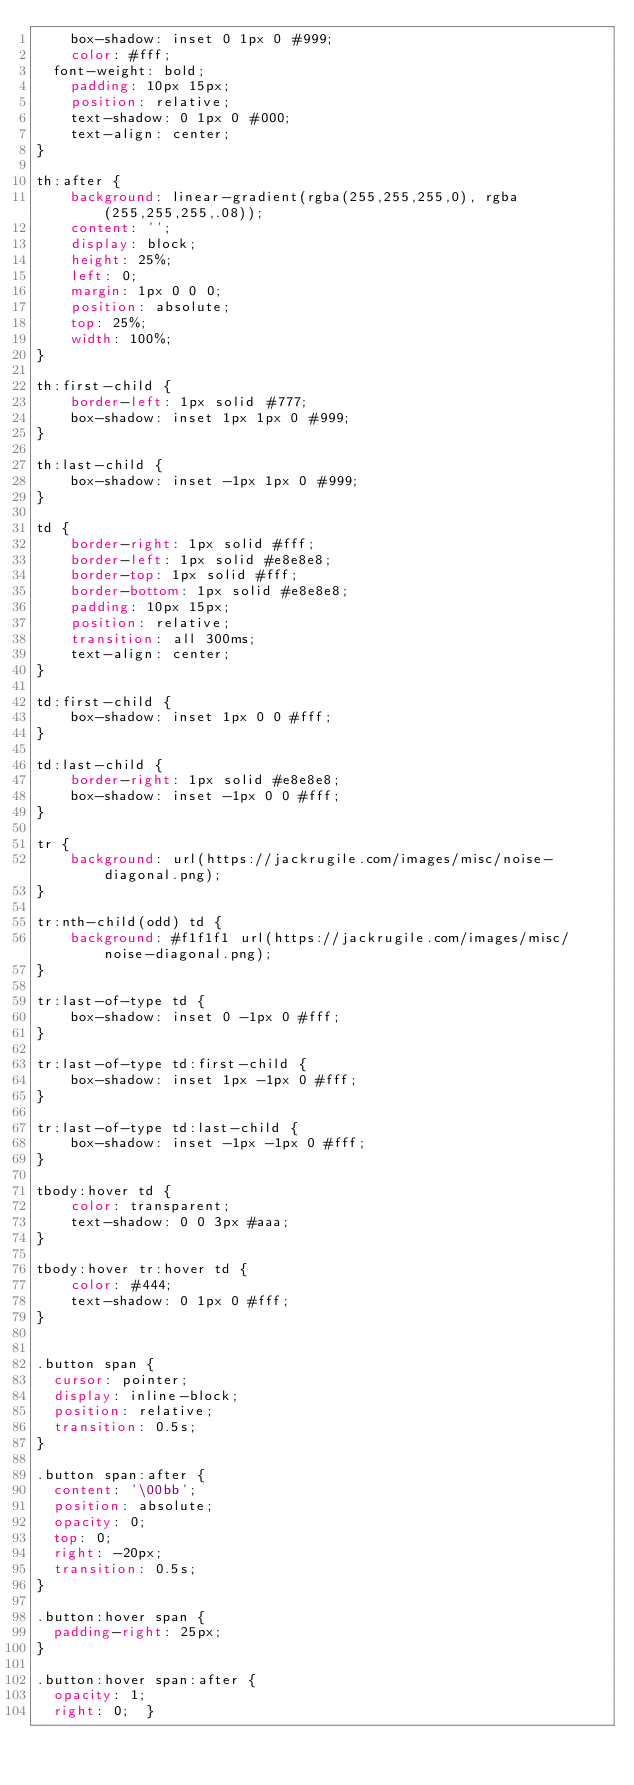Convert code to text. <code><loc_0><loc_0><loc_500><loc_500><_CSS_>	box-shadow: inset 0 1px 0 #999;
	color: #fff;
  font-weight: bold;
	padding: 10px 15px;
	position: relative;
	text-shadow: 0 1px 0 #000;	
	text-align: center;
}

th:after {
	background: linear-gradient(rgba(255,255,255,0), rgba(255,255,255,.08));
	content: '';
	display: block;
	height: 25%;
	left: 0;
	margin: 1px 0 0 0;
	position: absolute;
	top: 25%;
	width: 100%;
}

th:first-child {
	border-left: 1px solid #777;	
	box-shadow: inset 1px 1px 0 #999;
}

th:last-child {
	box-shadow: inset -1px 1px 0 #999;
}

td {
	border-right: 1px solid #fff;
	border-left: 1px solid #e8e8e8;
	border-top: 1px solid #fff;
	border-bottom: 1px solid #e8e8e8;
	padding: 10px 15px;
	position: relative;
	transition: all 300ms;
	text-align: center;
}

td:first-child {
	box-shadow: inset 1px 0 0 #fff;
}	

td:last-child {
	border-right: 1px solid #e8e8e8;
	box-shadow: inset -1px 0 0 #fff;
}	

tr {
	background: url(https://jackrugile.com/images/misc/noise-diagonal.png);	
}

tr:nth-child(odd) td {
	background: #f1f1f1 url(https://jackrugile.com/images/misc/noise-diagonal.png);	
}

tr:last-of-type td {
	box-shadow: inset 0 -1px 0 #fff; 
}

tr:last-of-type td:first-child {
	box-shadow: inset 1px -1px 0 #fff;
}	

tr:last-of-type td:last-child {
	box-shadow: inset -1px -1px 0 #fff;
}	

tbody:hover td {
	color: transparent;
	text-shadow: 0 0 3px #aaa;
}

tbody:hover tr:hover td {
	color: #444;
	text-shadow: 0 1px 0 #fff;
}


.button span {
  cursor: pointer;
  display: inline-block;
  position: relative;
  transition: 0.5s;
}

.button span:after {
  content: '\00bb';
  position: absolute;
  opacity: 0;
  top: 0;
  right: -20px;
  transition: 0.5s;
}

.button:hover span {
  padding-right: 25px;
}

.button:hover span:after {
  opacity: 1;
  right: 0;  }        
    
</code> 